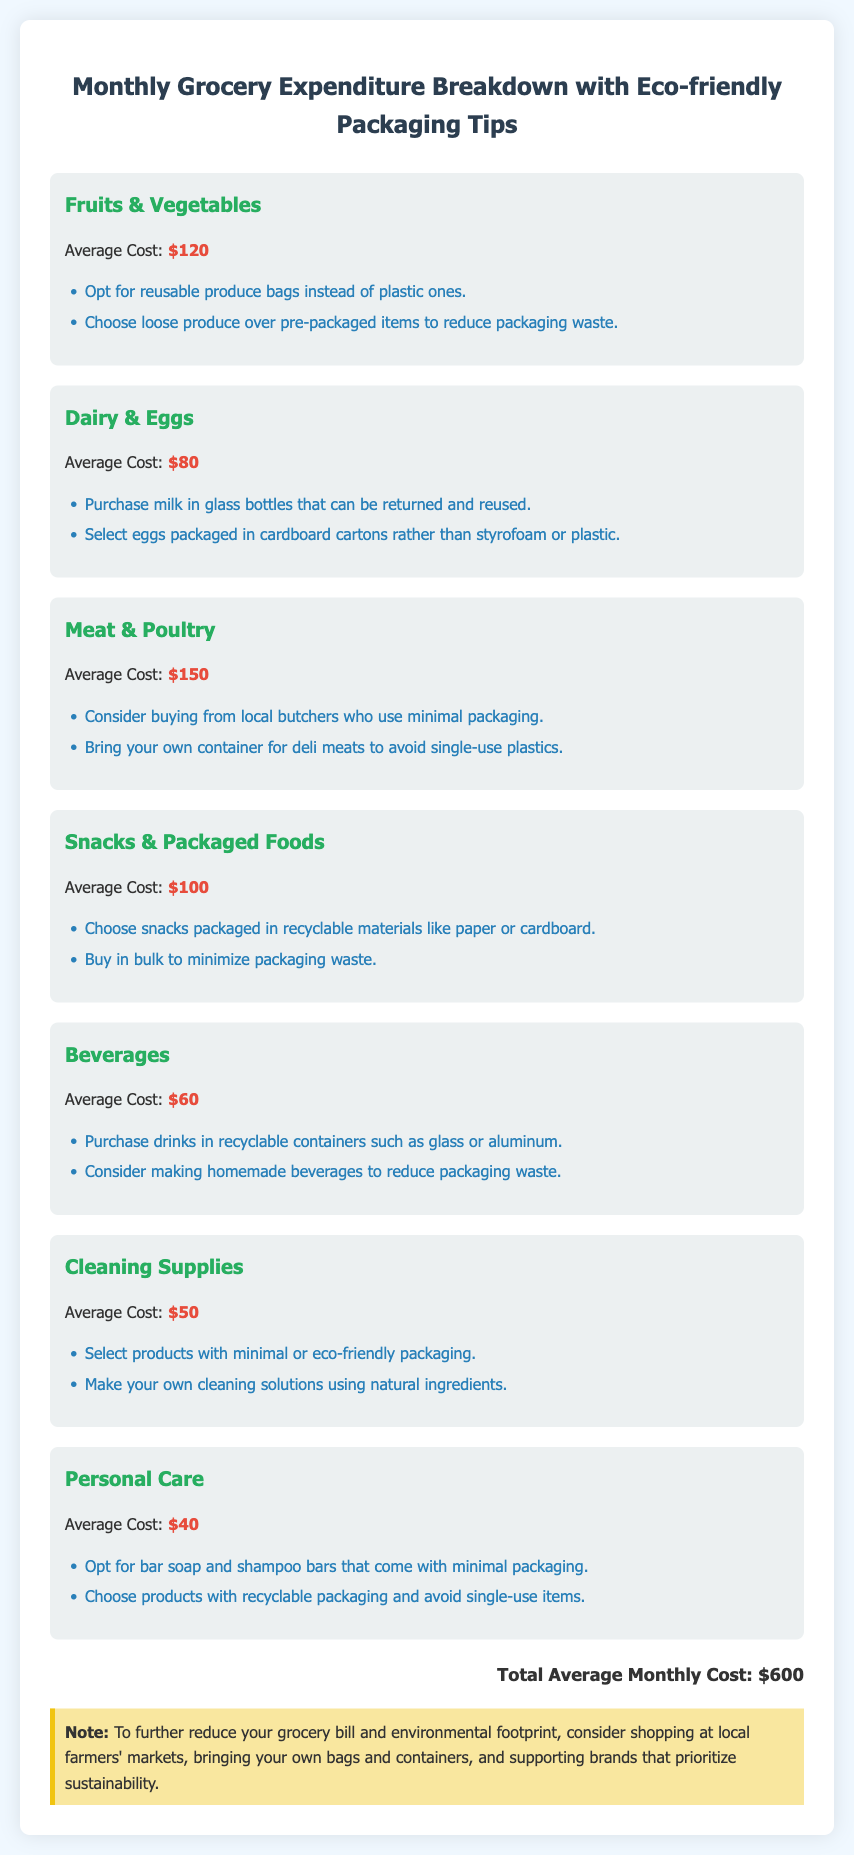What is the average cost for Fruits & Vegetables? The average cost for Fruits & Vegetables is listed in the document as $120.
Answer: $120 How much do you spend on Dairy & Eggs monthly? The document states the average cost for Dairy & Eggs is $80.
Answer: $80 What is one eco-friendly tip for purchasing snacks? The document suggests choosing snacks packaged in recyclable materials like paper or cardboard as an eco-friendly tip.
Answer: Choose snacks packaged in recyclable materials How much is the total average monthly cost? The total average monthly cost is presented in the document as $600.
Answer: $600 What eco-friendly alternative is suggested for cleaning supplies? The document recommends selecting products with minimal or eco-friendly packaging for cleaning supplies.
Answer: Minimal or eco-friendly packaging What is the average cost for Meat & Poultry? The document indicates the average cost for Meat & Poultry is $150.
Answer: $150 How can you further reduce your grocery bill? The document advises shopping at local farmers' markets to further reduce your grocery bill.
Answer: Shopping at local farmers' markets What type of cartons are preferred for eggs? The document recommends selecting eggs packaged in cardboard cartons.
Answer: Cardboard cartons 